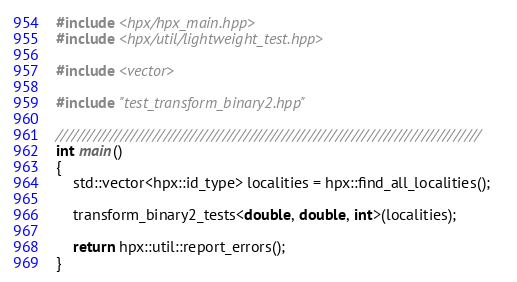<code> <loc_0><loc_0><loc_500><loc_500><_C++_>
#include <hpx/hpx_main.hpp>
#include <hpx/util/lightweight_test.hpp>

#include <vector>

#include "test_transform_binary2.hpp"

///////////////////////////////////////////////////////////////////////////////
int main()
{
    std::vector<hpx::id_type> localities = hpx::find_all_localities();

    transform_binary2_tests<double, double, int>(localities);

    return hpx::util::report_errors();
}
</code> 